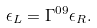<formula> <loc_0><loc_0><loc_500><loc_500>\epsilon _ { L } = \Gamma ^ { 0 9 } \epsilon _ { R } .</formula> 